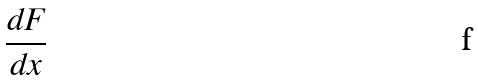Convert formula to latex. <formula><loc_0><loc_0><loc_500><loc_500>\frac { d F } { d x }</formula> 